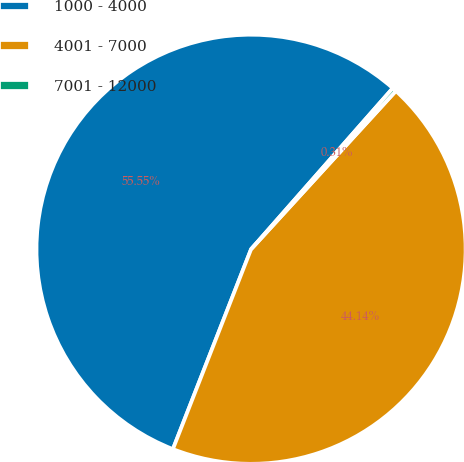Convert chart. <chart><loc_0><loc_0><loc_500><loc_500><pie_chart><fcel>1000 - 4000<fcel>4001 - 7000<fcel>7001 - 12000<nl><fcel>55.55%<fcel>44.14%<fcel>0.31%<nl></chart> 